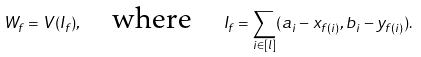Convert formula to latex. <formula><loc_0><loc_0><loc_500><loc_500>W _ { f } = V ( I _ { f } ) , \quad \text {where} \quad I _ { f } = \sum _ { i \in [ l ] } ( a _ { i } - x _ { f ( i ) } , b _ { i } - y _ { f ( i ) } ) .</formula> 